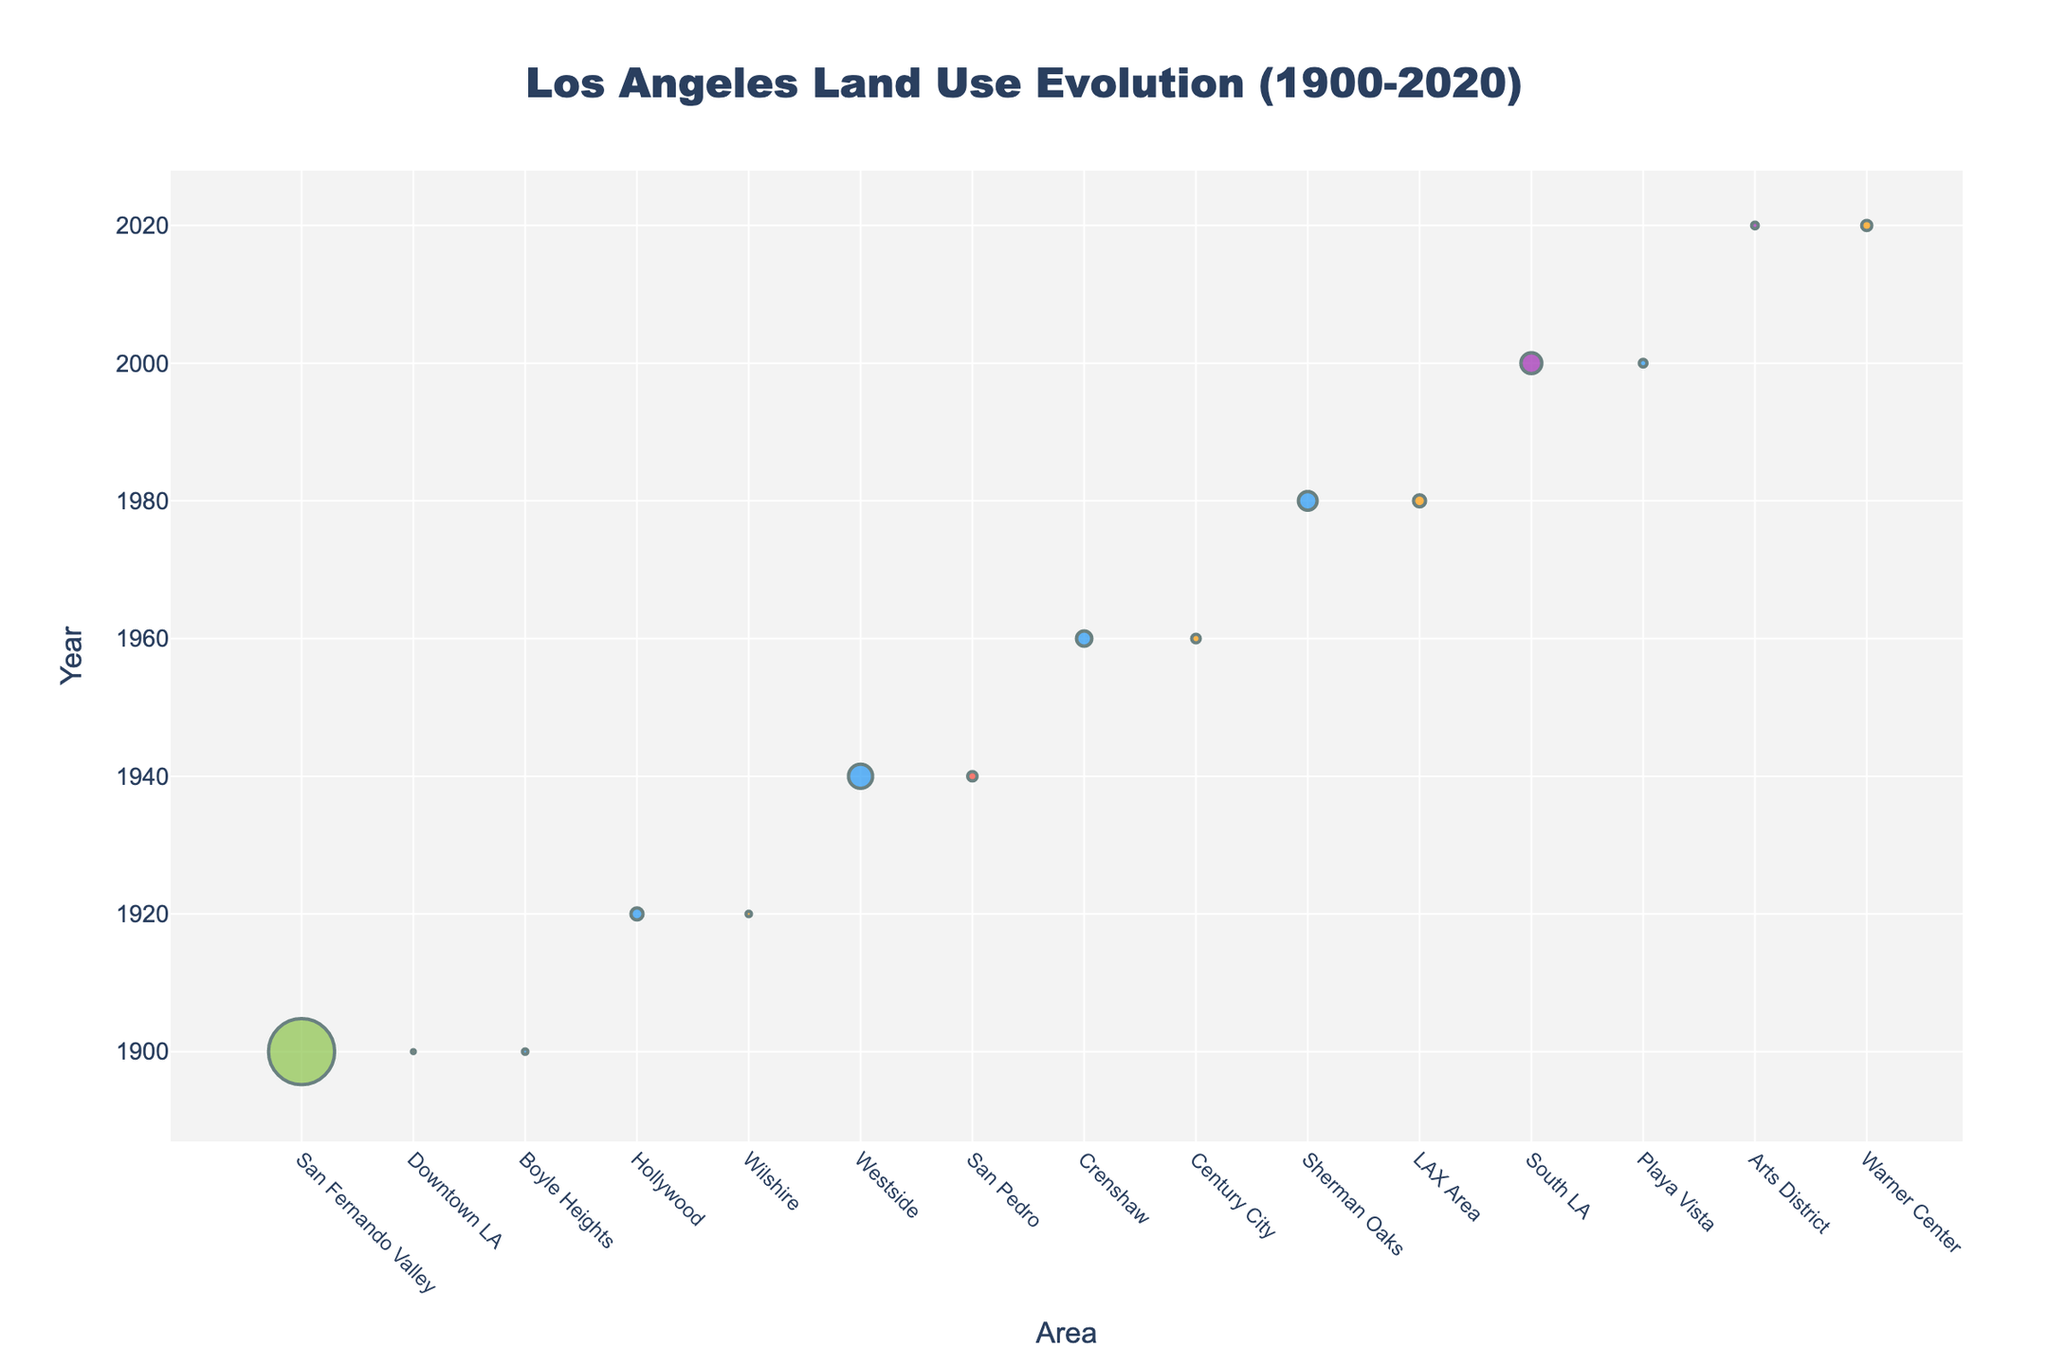How many different land use types are represented in the year 1960? Look at the markers corresponding to the year 1960 and note the different color codes representing the types. The types are Residential (blue) and Commercial (orange), which gives 2 different types.
Answer: 2 Which area had the highest amount of agricultural land in 1900? Identify the areas labeled in 1900 and note the type "Agricultural." The San Fernando Valley area has 150,000 acres, the highest among those labeled.
Answer: San Fernando Valley Between 1940 and 1980, how did the amount of residential land use in Sherman Oaks change in comparison to the Westside? Compare the residential land use in Westside in 1940 (20,000 acres) to Sherman Oaks in 1980 (12,000 acres). Sherman Oaks had 8,000 fewer acres than Westside.
Answer: Westside had 8,000 more acres How many acres of commercial land existed in Century City in 1960 and Warner Center in 2020 combined? Add the acreage values for Century City in 1960 (2,500 acres) and Warner Center in 2020 (3,500 acres) together: 2,500 + 3,500 = 6,000 acres.
Answer: 6,000 acres What is the predominant land use type in 2000 based on acre size? Examine the data for 2000, which includes South LA (Mixed Use, 15,000 acres), and Playa Vista (Residential, 2,000 acres). The predominant use by acre size is Mixed Use.
Answer: Mixed Use Did the commercial land use in the Downtown LA area increase or decrease from 1900 to 2020? Note the commercial land use in Downtown LA in 1900 (500 acres). Since there is no subsequent data point for Downtown LA in 2020 in the given dataset, the comparison cannot be made directly.
Answer: Indeterminate from data Which area had the largest amount of mixed-use land in 2020, and how many acres does it cover? Identify mixed-use land in 2020. The Arts District area has 1,500 acres of mixed-use land. Since it's the only data point for mixed use in 2020, it is the largest by default.
Answer: Arts District, 1,500 acres What changes are seen in the classification of land in San Fernando Valley from 1900 to 2020? Check for the San Fernando Valley data in both 1900 and 2020. In 1900 it was Agricultural with 150,000 acres. There is no data for San Fernando Valley in 2020 in the dataset provided, so subsequent shifts can't be determined from this dataset alone.
Answer: Data insufficient for comparison How does the number of areas designated as residential in 1980 compare to that in 2000? Identify the residential areas for 1980 (Sherman Oaks) and 2000 (Playa Vista). Both years show 1 residential area each.
Answer: Equal What is the overall trend in land use type throughout the years based on the figure? By reviewing the different data points from 1900 to 2020, there is a trend of shifting from predominantly agricultural to increasingly residential, commercial, and mixed-use areas over time.
Answer: Shift from agricultural to residential, commercial, and mixed-use 